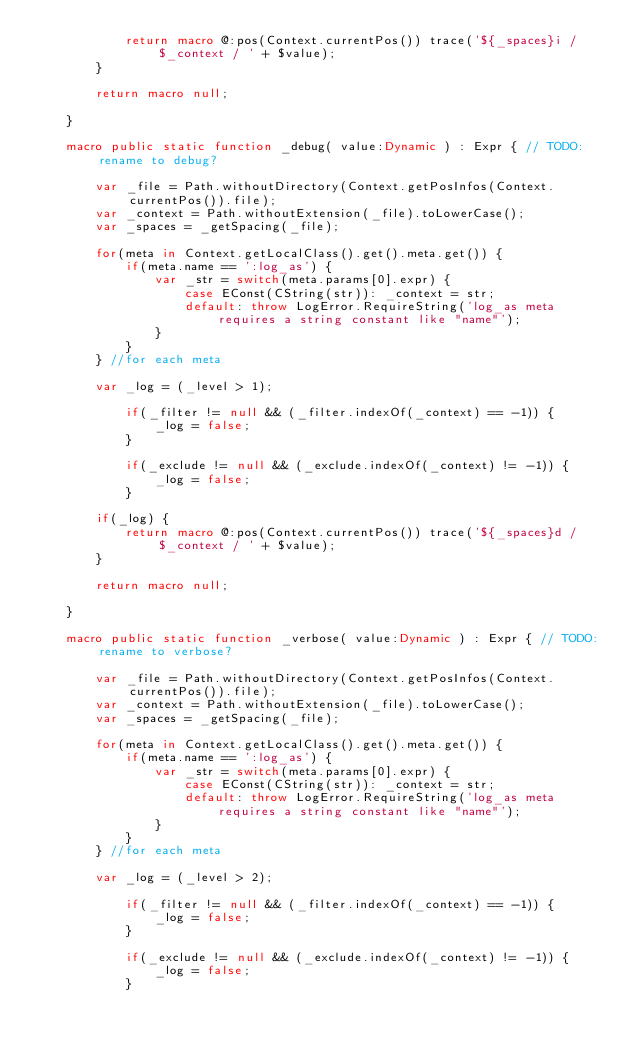<code> <loc_0><loc_0><loc_500><loc_500><_Haxe_>			return macro @:pos(Context.currentPos()) trace('${_spaces}i / $_context / ' + $value);
		}

		return macro null;

	}

	macro public static function _debug( value:Dynamic ) : Expr { // TODO: rename to debug?

		var _file = Path.withoutDirectory(Context.getPosInfos(Context.currentPos()).file);
		var _context = Path.withoutExtension(_file).toLowerCase();
		var _spaces = _getSpacing(_file);

		for(meta in Context.getLocalClass().get().meta.get()) {
			if(meta.name == ':log_as') {
				var _str = switch(meta.params[0].expr) {
					case EConst(CString(str)): _context = str;
					default: throw LogError.RequireString('log_as meta requires a string constant like "name"');
				}
			}
		} //for each meta

		var _log = (_level > 1);

			if(_filter != null && (_filter.indexOf(_context) == -1)) {
				_log = false;
			}

			if(_exclude != null && (_exclude.indexOf(_context) != -1)) {
				_log = false;
			}

		if(_log) {
			return macro @:pos(Context.currentPos()) trace('${_spaces}d / $_context / ' + $value);
		}

		return macro null;

	}

	macro public static function _verbose( value:Dynamic ) : Expr { // TODO: rename to verbose?

		var _file = Path.withoutDirectory(Context.getPosInfos(Context.currentPos()).file);
		var _context = Path.withoutExtension(_file).toLowerCase();
		var _spaces = _getSpacing(_file);

		for(meta in Context.getLocalClass().get().meta.get()) {
			if(meta.name == ':log_as') {
				var _str = switch(meta.params[0].expr) {
					case EConst(CString(str)): _context = str;
					default: throw LogError.RequireString('log_as meta requires a string constant like "name"');
				}
			}
		} //for each meta

		var _log = (_level > 2);

			if(_filter != null && (_filter.indexOf(_context) == -1)) {
				_log = false;
			}

			if(_exclude != null && (_exclude.indexOf(_context) != -1)) {
				_log = false;
			}
</code> 